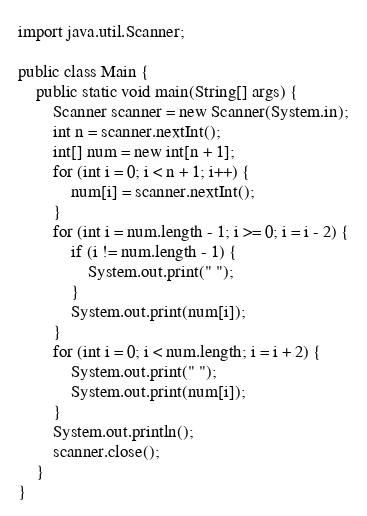Convert code to text. <code><loc_0><loc_0><loc_500><loc_500><_Java_>import java.util.Scanner;

public class Main {
	public static void main(String[] args) {	
		Scanner scanner = new Scanner(System.in);
		int n = scanner.nextInt();
		int[] num = new int[n + 1];
		for (int i = 0; i < n + 1; i++) {
			num[i] = scanner.nextInt();
		}
		for (int i = num.length - 1; i >= 0; i = i - 2) {
			if (i != num.length - 1) {
				System.out.print(" ");
			}
			System.out.print(num[i]);
		}
		for (int i = 0; i < num.length; i = i + 2) {
			System.out.print(" ");
			System.out.print(num[i]);
		}
		System.out.println();
		scanner.close();
	}
}
</code> 